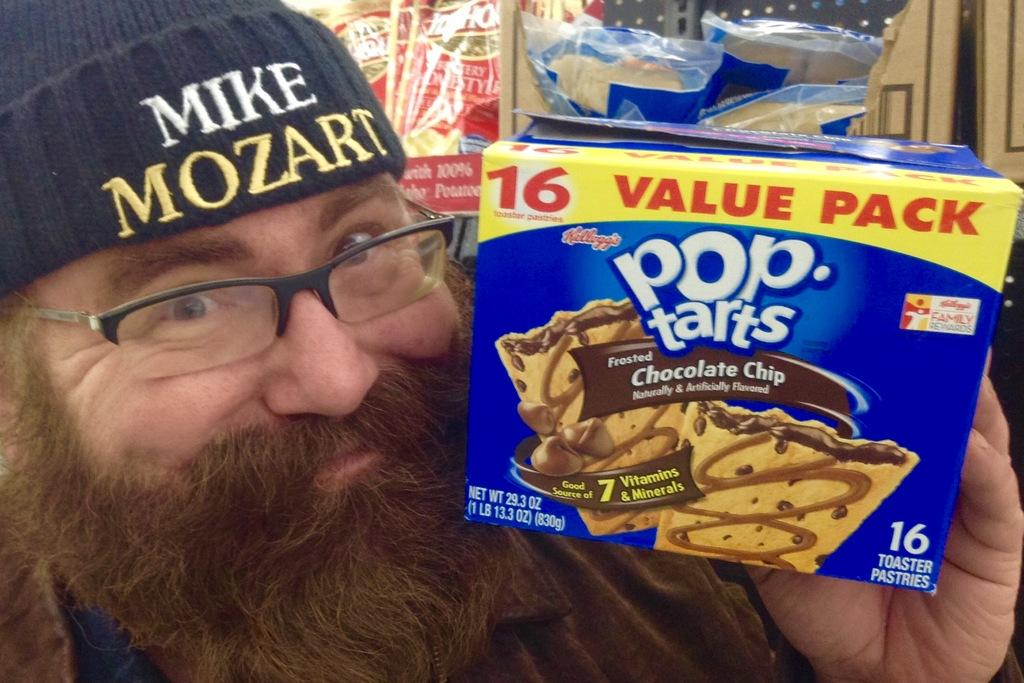What is the main subject of the image? There is a person in the image. What is the person holding in the image? The person is holding a pack of chocolate chips. Can you describe the background of the image? There are objects in the background of the image. What type of dog can be seen playing with the chocolate chips in the image? There is no dog present in the image, and the chocolate chips are being held by the person, not played with. 